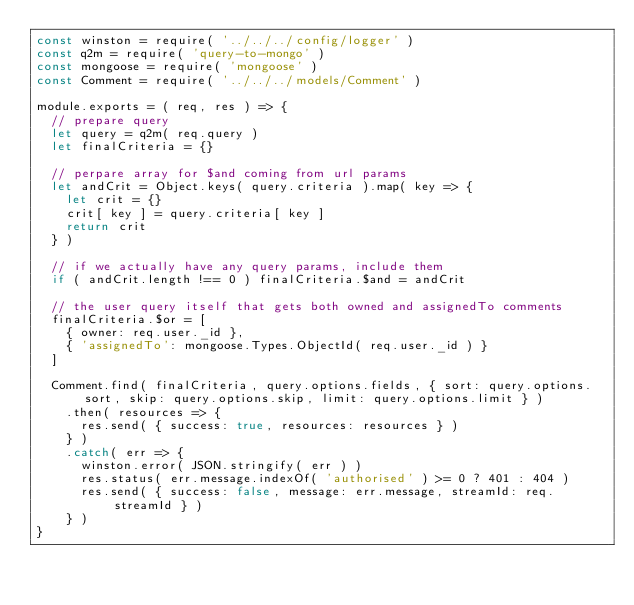Convert code to text. <code><loc_0><loc_0><loc_500><loc_500><_JavaScript_>const winston = require( '../../../config/logger' )
const q2m = require( 'query-to-mongo' )
const mongoose = require( 'mongoose' )
const Comment = require( '../../../models/Comment' )

module.exports = ( req, res ) => {
  // prepare query
  let query = q2m( req.query )
  let finalCriteria = {}

  // perpare array for $and coming from url params
  let andCrit = Object.keys( query.criteria ).map( key => {
    let crit = {}
    crit[ key ] = query.criteria[ key ]
    return crit
  } )

  // if we actually have any query params, include them
  if ( andCrit.length !== 0 ) finalCriteria.$and = andCrit

  // the user query itself that gets both owned and assignedTo comments
  finalCriteria.$or = [
    { owner: req.user._id },
    { 'assignedTo': mongoose.Types.ObjectId( req.user._id ) }
  ]

  Comment.find( finalCriteria, query.options.fields, { sort: query.options.sort, skip: query.options.skip, limit: query.options.limit } )
    .then( resources => {
      res.send( { success: true, resources: resources } )
    } )
    .catch( err => {
      winston.error( JSON.stringify( err ) )
      res.status( err.message.indexOf( 'authorised' ) >= 0 ? 401 : 404 )
      res.send( { success: false, message: err.message, streamId: req.streamId } )
    } )
}
</code> 